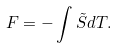Convert formula to latex. <formula><loc_0><loc_0><loc_500><loc_500>F = - \int \tilde { S } d T .</formula> 